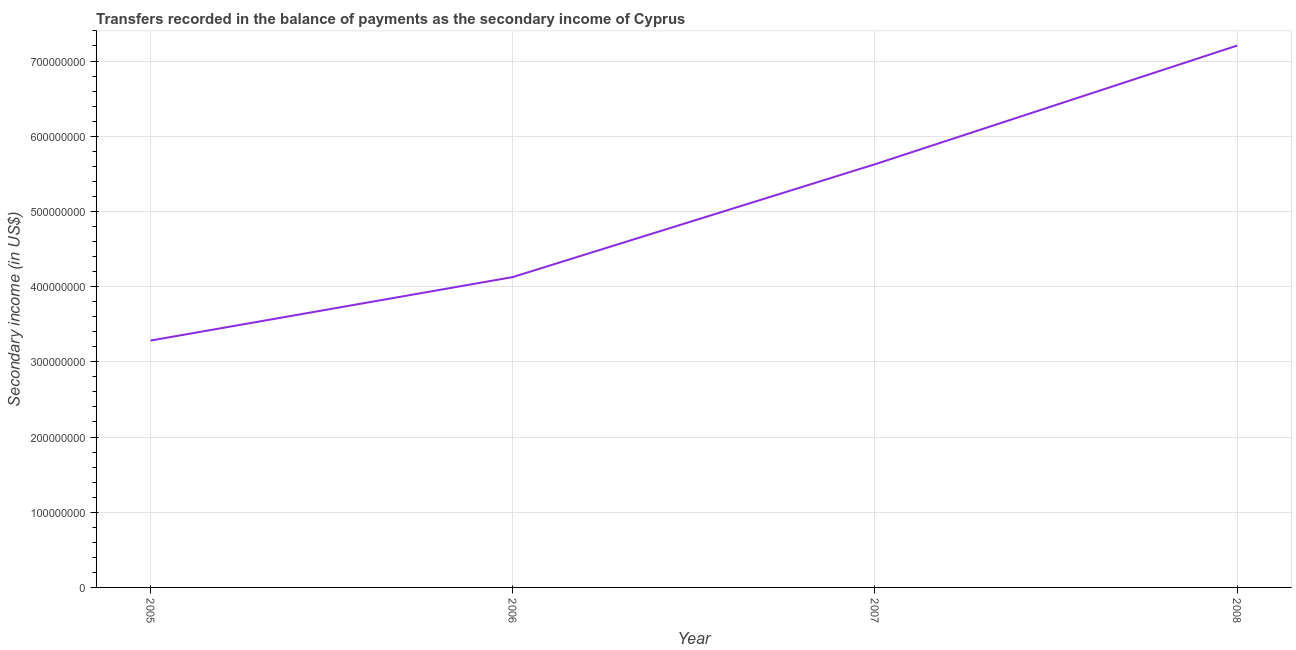What is the amount of secondary income in 2007?
Offer a very short reply. 5.63e+08. Across all years, what is the maximum amount of secondary income?
Provide a short and direct response. 7.21e+08. Across all years, what is the minimum amount of secondary income?
Your answer should be compact. 3.28e+08. In which year was the amount of secondary income maximum?
Keep it short and to the point. 2008. In which year was the amount of secondary income minimum?
Offer a terse response. 2005. What is the sum of the amount of secondary income?
Your answer should be compact. 2.02e+09. What is the difference between the amount of secondary income in 2007 and 2008?
Ensure brevity in your answer.  -1.58e+08. What is the average amount of secondary income per year?
Ensure brevity in your answer.  5.06e+08. What is the median amount of secondary income?
Ensure brevity in your answer.  4.88e+08. In how many years, is the amount of secondary income greater than 80000000 US$?
Your answer should be compact. 4. Do a majority of the years between 2006 and 2005 (inclusive) have amount of secondary income greater than 200000000 US$?
Offer a terse response. No. What is the ratio of the amount of secondary income in 2007 to that in 2008?
Keep it short and to the point. 0.78. Is the difference between the amount of secondary income in 2005 and 2006 greater than the difference between any two years?
Your answer should be very brief. No. What is the difference between the highest and the second highest amount of secondary income?
Offer a terse response. 1.58e+08. What is the difference between the highest and the lowest amount of secondary income?
Give a very brief answer. 3.92e+08. In how many years, is the amount of secondary income greater than the average amount of secondary income taken over all years?
Your response must be concise. 2. How many lines are there?
Offer a terse response. 1. How many years are there in the graph?
Your answer should be compact. 4. What is the difference between two consecutive major ticks on the Y-axis?
Offer a very short reply. 1.00e+08. Does the graph contain grids?
Ensure brevity in your answer.  Yes. What is the title of the graph?
Keep it short and to the point. Transfers recorded in the balance of payments as the secondary income of Cyprus. What is the label or title of the Y-axis?
Provide a short and direct response. Secondary income (in US$). What is the Secondary income (in US$) in 2005?
Keep it short and to the point. 3.28e+08. What is the Secondary income (in US$) of 2006?
Your answer should be compact. 4.13e+08. What is the Secondary income (in US$) of 2007?
Provide a succinct answer. 5.63e+08. What is the Secondary income (in US$) in 2008?
Your answer should be compact. 7.21e+08. What is the difference between the Secondary income (in US$) in 2005 and 2006?
Offer a terse response. -8.44e+07. What is the difference between the Secondary income (in US$) in 2005 and 2007?
Your answer should be very brief. -2.34e+08. What is the difference between the Secondary income (in US$) in 2005 and 2008?
Ensure brevity in your answer.  -3.92e+08. What is the difference between the Secondary income (in US$) in 2006 and 2007?
Offer a very short reply. -1.50e+08. What is the difference between the Secondary income (in US$) in 2006 and 2008?
Give a very brief answer. -3.08e+08. What is the difference between the Secondary income (in US$) in 2007 and 2008?
Make the answer very short. -1.58e+08. What is the ratio of the Secondary income (in US$) in 2005 to that in 2006?
Provide a short and direct response. 0.8. What is the ratio of the Secondary income (in US$) in 2005 to that in 2007?
Provide a short and direct response. 0.58. What is the ratio of the Secondary income (in US$) in 2005 to that in 2008?
Provide a succinct answer. 0.46. What is the ratio of the Secondary income (in US$) in 2006 to that in 2007?
Make the answer very short. 0.73. What is the ratio of the Secondary income (in US$) in 2006 to that in 2008?
Your answer should be very brief. 0.57. What is the ratio of the Secondary income (in US$) in 2007 to that in 2008?
Provide a short and direct response. 0.78. 